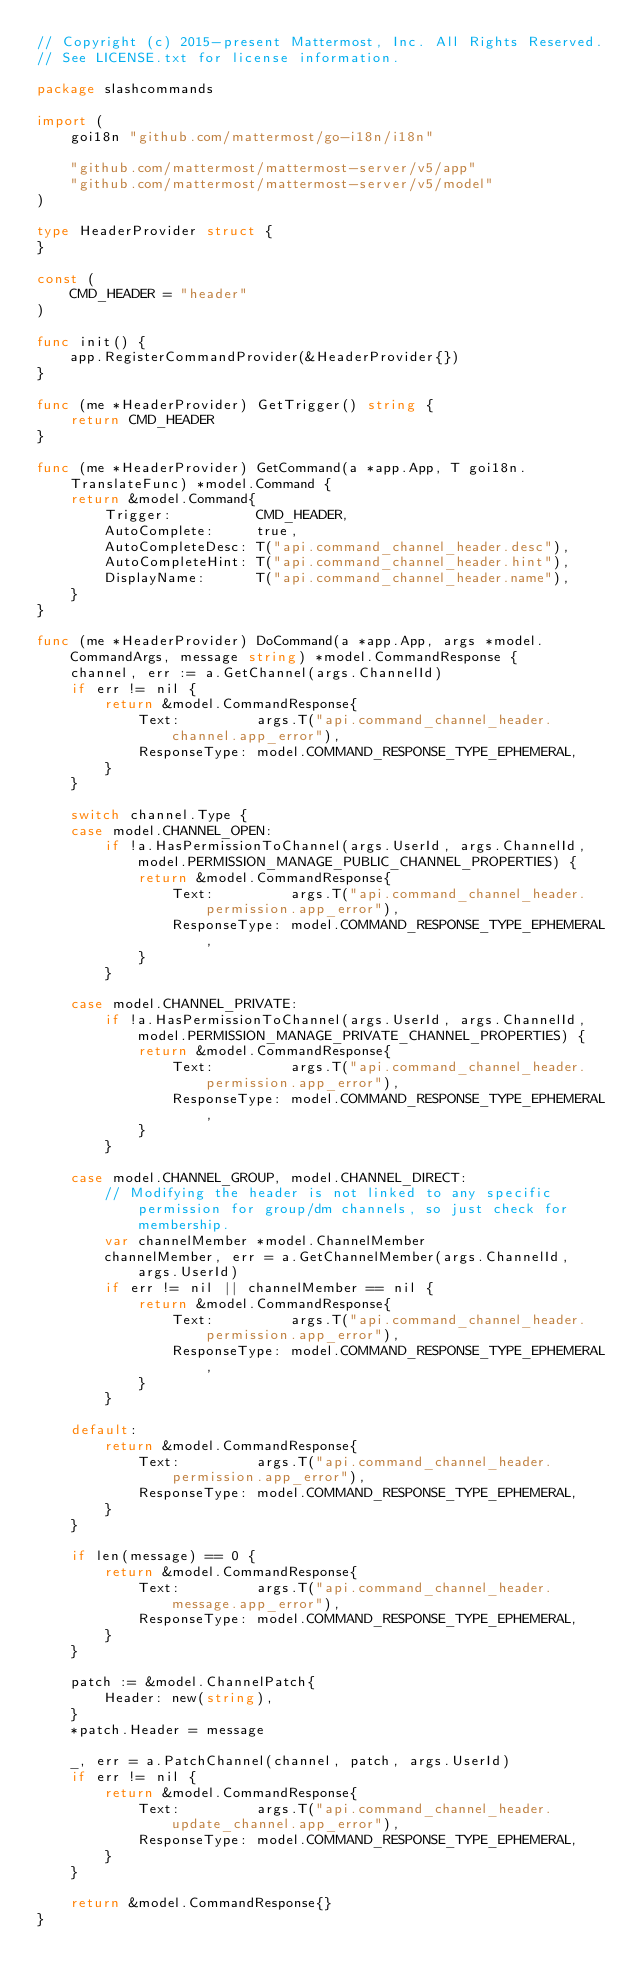Convert code to text. <code><loc_0><loc_0><loc_500><loc_500><_Go_>// Copyright (c) 2015-present Mattermost, Inc. All Rights Reserved.
// See LICENSE.txt for license information.

package slashcommands

import (
	goi18n "github.com/mattermost/go-i18n/i18n"

	"github.com/mattermost/mattermost-server/v5/app"
	"github.com/mattermost/mattermost-server/v5/model"
)

type HeaderProvider struct {
}

const (
	CMD_HEADER = "header"
)

func init() {
	app.RegisterCommandProvider(&HeaderProvider{})
}

func (me *HeaderProvider) GetTrigger() string {
	return CMD_HEADER
}

func (me *HeaderProvider) GetCommand(a *app.App, T goi18n.TranslateFunc) *model.Command {
	return &model.Command{
		Trigger:          CMD_HEADER,
		AutoComplete:     true,
		AutoCompleteDesc: T("api.command_channel_header.desc"),
		AutoCompleteHint: T("api.command_channel_header.hint"),
		DisplayName:      T("api.command_channel_header.name"),
	}
}

func (me *HeaderProvider) DoCommand(a *app.App, args *model.CommandArgs, message string) *model.CommandResponse {
	channel, err := a.GetChannel(args.ChannelId)
	if err != nil {
		return &model.CommandResponse{
			Text:         args.T("api.command_channel_header.channel.app_error"),
			ResponseType: model.COMMAND_RESPONSE_TYPE_EPHEMERAL,
		}
	}

	switch channel.Type {
	case model.CHANNEL_OPEN:
		if !a.HasPermissionToChannel(args.UserId, args.ChannelId, model.PERMISSION_MANAGE_PUBLIC_CHANNEL_PROPERTIES) {
			return &model.CommandResponse{
				Text:         args.T("api.command_channel_header.permission.app_error"),
				ResponseType: model.COMMAND_RESPONSE_TYPE_EPHEMERAL,
			}
		}

	case model.CHANNEL_PRIVATE:
		if !a.HasPermissionToChannel(args.UserId, args.ChannelId, model.PERMISSION_MANAGE_PRIVATE_CHANNEL_PROPERTIES) {
			return &model.CommandResponse{
				Text:         args.T("api.command_channel_header.permission.app_error"),
				ResponseType: model.COMMAND_RESPONSE_TYPE_EPHEMERAL,
			}
		}

	case model.CHANNEL_GROUP, model.CHANNEL_DIRECT:
		// Modifying the header is not linked to any specific permission for group/dm channels, so just check for membership.
		var channelMember *model.ChannelMember
		channelMember, err = a.GetChannelMember(args.ChannelId, args.UserId)
		if err != nil || channelMember == nil {
			return &model.CommandResponse{
				Text:         args.T("api.command_channel_header.permission.app_error"),
				ResponseType: model.COMMAND_RESPONSE_TYPE_EPHEMERAL,
			}
		}

	default:
		return &model.CommandResponse{
			Text:         args.T("api.command_channel_header.permission.app_error"),
			ResponseType: model.COMMAND_RESPONSE_TYPE_EPHEMERAL,
		}
	}

	if len(message) == 0 {
		return &model.CommandResponse{
			Text:         args.T("api.command_channel_header.message.app_error"),
			ResponseType: model.COMMAND_RESPONSE_TYPE_EPHEMERAL,
		}
	}

	patch := &model.ChannelPatch{
		Header: new(string),
	}
	*patch.Header = message

	_, err = a.PatchChannel(channel, patch, args.UserId)
	if err != nil {
		return &model.CommandResponse{
			Text:         args.T("api.command_channel_header.update_channel.app_error"),
			ResponseType: model.COMMAND_RESPONSE_TYPE_EPHEMERAL,
		}
	}

	return &model.CommandResponse{}
}
</code> 